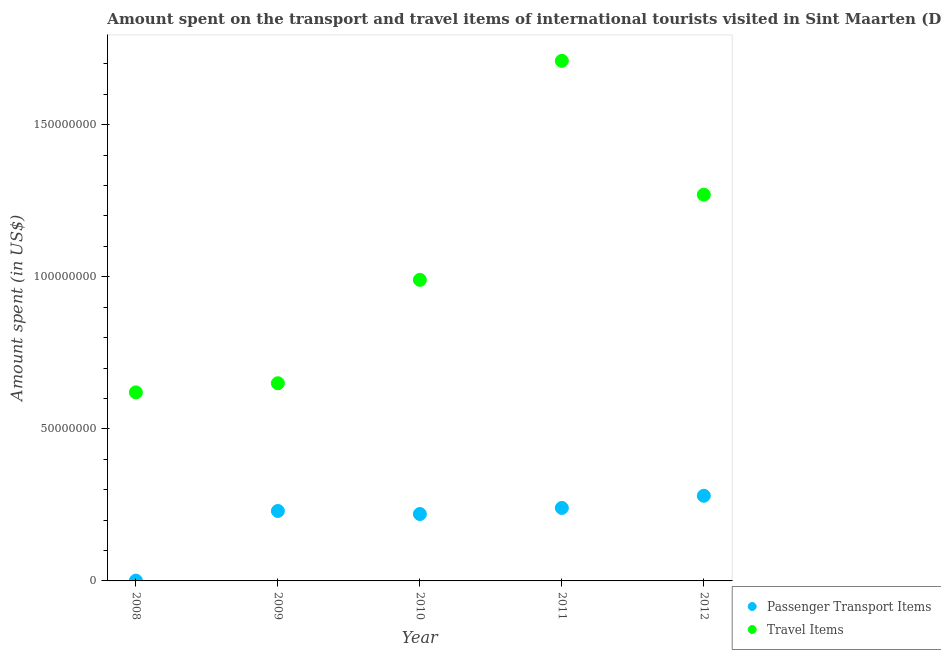Is the number of dotlines equal to the number of legend labels?
Provide a short and direct response. Yes. What is the amount spent on passenger transport items in 2009?
Give a very brief answer. 2.30e+07. Across all years, what is the maximum amount spent on passenger transport items?
Your response must be concise. 2.80e+07. Across all years, what is the minimum amount spent on passenger transport items?
Your answer should be very brief. 1.00e+05. In which year was the amount spent in travel items maximum?
Provide a succinct answer. 2011. What is the total amount spent in travel items in the graph?
Provide a short and direct response. 5.24e+08. What is the difference between the amount spent in travel items in 2008 and that in 2011?
Offer a very short reply. -1.09e+08. What is the difference between the amount spent on passenger transport items in 2010 and the amount spent in travel items in 2012?
Your answer should be very brief. -1.05e+08. What is the average amount spent on passenger transport items per year?
Ensure brevity in your answer.  1.94e+07. In the year 2012, what is the difference between the amount spent in travel items and amount spent on passenger transport items?
Offer a very short reply. 9.90e+07. In how many years, is the amount spent in travel items greater than 30000000 US$?
Give a very brief answer. 5. What is the ratio of the amount spent in travel items in 2009 to that in 2011?
Keep it short and to the point. 0.38. Is the difference between the amount spent on passenger transport items in 2008 and 2009 greater than the difference between the amount spent in travel items in 2008 and 2009?
Give a very brief answer. No. What is the difference between the highest and the second highest amount spent in travel items?
Your answer should be very brief. 4.40e+07. What is the difference between the highest and the lowest amount spent in travel items?
Your response must be concise. 1.09e+08. In how many years, is the amount spent on passenger transport items greater than the average amount spent on passenger transport items taken over all years?
Your answer should be very brief. 4. Is the sum of the amount spent on passenger transport items in 2009 and 2011 greater than the maximum amount spent in travel items across all years?
Offer a very short reply. No. Is the amount spent on passenger transport items strictly less than the amount spent in travel items over the years?
Provide a succinct answer. Yes. How many dotlines are there?
Keep it short and to the point. 2. What is the difference between two consecutive major ticks on the Y-axis?
Your answer should be very brief. 5.00e+07. Does the graph contain any zero values?
Give a very brief answer. No. How are the legend labels stacked?
Keep it short and to the point. Vertical. What is the title of the graph?
Make the answer very short. Amount spent on the transport and travel items of international tourists visited in Sint Maarten (Dutch part). What is the label or title of the Y-axis?
Give a very brief answer. Amount spent (in US$). What is the Amount spent (in US$) in Travel Items in 2008?
Give a very brief answer. 6.20e+07. What is the Amount spent (in US$) of Passenger Transport Items in 2009?
Give a very brief answer. 2.30e+07. What is the Amount spent (in US$) of Travel Items in 2009?
Your answer should be very brief. 6.50e+07. What is the Amount spent (in US$) in Passenger Transport Items in 2010?
Provide a short and direct response. 2.20e+07. What is the Amount spent (in US$) in Travel Items in 2010?
Make the answer very short. 9.90e+07. What is the Amount spent (in US$) of Passenger Transport Items in 2011?
Ensure brevity in your answer.  2.40e+07. What is the Amount spent (in US$) of Travel Items in 2011?
Your answer should be compact. 1.71e+08. What is the Amount spent (in US$) of Passenger Transport Items in 2012?
Ensure brevity in your answer.  2.80e+07. What is the Amount spent (in US$) in Travel Items in 2012?
Your answer should be very brief. 1.27e+08. Across all years, what is the maximum Amount spent (in US$) in Passenger Transport Items?
Offer a terse response. 2.80e+07. Across all years, what is the maximum Amount spent (in US$) of Travel Items?
Your response must be concise. 1.71e+08. Across all years, what is the minimum Amount spent (in US$) of Travel Items?
Your response must be concise. 6.20e+07. What is the total Amount spent (in US$) in Passenger Transport Items in the graph?
Provide a succinct answer. 9.71e+07. What is the total Amount spent (in US$) in Travel Items in the graph?
Provide a succinct answer. 5.24e+08. What is the difference between the Amount spent (in US$) in Passenger Transport Items in 2008 and that in 2009?
Your response must be concise. -2.29e+07. What is the difference between the Amount spent (in US$) of Travel Items in 2008 and that in 2009?
Make the answer very short. -3.00e+06. What is the difference between the Amount spent (in US$) in Passenger Transport Items in 2008 and that in 2010?
Offer a terse response. -2.19e+07. What is the difference between the Amount spent (in US$) in Travel Items in 2008 and that in 2010?
Your answer should be very brief. -3.70e+07. What is the difference between the Amount spent (in US$) of Passenger Transport Items in 2008 and that in 2011?
Offer a very short reply. -2.39e+07. What is the difference between the Amount spent (in US$) of Travel Items in 2008 and that in 2011?
Offer a terse response. -1.09e+08. What is the difference between the Amount spent (in US$) in Passenger Transport Items in 2008 and that in 2012?
Your answer should be very brief. -2.79e+07. What is the difference between the Amount spent (in US$) of Travel Items in 2008 and that in 2012?
Offer a terse response. -6.50e+07. What is the difference between the Amount spent (in US$) in Travel Items in 2009 and that in 2010?
Keep it short and to the point. -3.40e+07. What is the difference between the Amount spent (in US$) in Travel Items in 2009 and that in 2011?
Provide a short and direct response. -1.06e+08. What is the difference between the Amount spent (in US$) in Passenger Transport Items in 2009 and that in 2012?
Provide a succinct answer. -5.00e+06. What is the difference between the Amount spent (in US$) of Travel Items in 2009 and that in 2012?
Provide a succinct answer. -6.20e+07. What is the difference between the Amount spent (in US$) of Travel Items in 2010 and that in 2011?
Offer a very short reply. -7.20e+07. What is the difference between the Amount spent (in US$) of Passenger Transport Items in 2010 and that in 2012?
Offer a terse response. -6.00e+06. What is the difference between the Amount spent (in US$) of Travel Items in 2010 and that in 2012?
Make the answer very short. -2.80e+07. What is the difference between the Amount spent (in US$) in Travel Items in 2011 and that in 2012?
Keep it short and to the point. 4.40e+07. What is the difference between the Amount spent (in US$) of Passenger Transport Items in 2008 and the Amount spent (in US$) of Travel Items in 2009?
Your answer should be very brief. -6.49e+07. What is the difference between the Amount spent (in US$) in Passenger Transport Items in 2008 and the Amount spent (in US$) in Travel Items in 2010?
Your response must be concise. -9.89e+07. What is the difference between the Amount spent (in US$) in Passenger Transport Items in 2008 and the Amount spent (in US$) in Travel Items in 2011?
Keep it short and to the point. -1.71e+08. What is the difference between the Amount spent (in US$) in Passenger Transport Items in 2008 and the Amount spent (in US$) in Travel Items in 2012?
Offer a very short reply. -1.27e+08. What is the difference between the Amount spent (in US$) of Passenger Transport Items in 2009 and the Amount spent (in US$) of Travel Items in 2010?
Offer a very short reply. -7.60e+07. What is the difference between the Amount spent (in US$) in Passenger Transport Items in 2009 and the Amount spent (in US$) in Travel Items in 2011?
Offer a terse response. -1.48e+08. What is the difference between the Amount spent (in US$) in Passenger Transport Items in 2009 and the Amount spent (in US$) in Travel Items in 2012?
Make the answer very short. -1.04e+08. What is the difference between the Amount spent (in US$) in Passenger Transport Items in 2010 and the Amount spent (in US$) in Travel Items in 2011?
Provide a succinct answer. -1.49e+08. What is the difference between the Amount spent (in US$) of Passenger Transport Items in 2010 and the Amount spent (in US$) of Travel Items in 2012?
Your answer should be very brief. -1.05e+08. What is the difference between the Amount spent (in US$) of Passenger Transport Items in 2011 and the Amount spent (in US$) of Travel Items in 2012?
Offer a terse response. -1.03e+08. What is the average Amount spent (in US$) of Passenger Transport Items per year?
Keep it short and to the point. 1.94e+07. What is the average Amount spent (in US$) of Travel Items per year?
Provide a succinct answer. 1.05e+08. In the year 2008, what is the difference between the Amount spent (in US$) in Passenger Transport Items and Amount spent (in US$) in Travel Items?
Your answer should be very brief. -6.19e+07. In the year 2009, what is the difference between the Amount spent (in US$) in Passenger Transport Items and Amount spent (in US$) in Travel Items?
Ensure brevity in your answer.  -4.20e+07. In the year 2010, what is the difference between the Amount spent (in US$) of Passenger Transport Items and Amount spent (in US$) of Travel Items?
Keep it short and to the point. -7.70e+07. In the year 2011, what is the difference between the Amount spent (in US$) of Passenger Transport Items and Amount spent (in US$) of Travel Items?
Make the answer very short. -1.47e+08. In the year 2012, what is the difference between the Amount spent (in US$) of Passenger Transport Items and Amount spent (in US$) of Travel Items?
Provide a succinct answer. -9.90e+07. What is the ratio of the Amount spent (in US$) of Passenger Transport Items in 2008 to that in 2009?
Provide a succinct answer. 0. What is the ratio of the Amount spent (in US$) in Travel Items in 2008 to that in 2009?
Keep it short and to the point. 0.95. What is the ratio of the Amount spent (in US$) of Passenger Transport Items in 2008 to that in 2010?
Provide a short and direct response. 0. What is the ratio of the Amount spent (in US$) of Travel Items in 2008 to that in 2010?
Provide a short and direct response. 0.63. What is the ratio of the Amount spent (in US$) of Passenger Transport Items in 2008 to that in 2011?
Provide a short and direct response. 0. What is the ratio of the Amount spent (in US$) of Travel Items in 2008 to that in 2011?
Ensure brevity in your answer.  0.36. What is the ratio of the Amount spent (in US$) of Passenger Transport Items in 2008 to that in 2012?
Your answer should be compact. 0. What is the ratio of the Amount spent (in US$) in Travel Items in 2008 to that in 2012?
Ensure brevity in your answer.  0.49. What is the ratio of the Amount spent (in US$) in Passenger Transport Items in 2009 to that in 2010?
Provide a short and direct response. 1.05. What is the ratio of the Amount spent (in US$) in Travel Items in 2009 to that in 2010?
Keep it short and to the point. 0.66. What is the ratio of the Amount spent (in US$) in Travel Items in 2009 to that in 2011?
Offer a terse response. 0.38. What is the ratio of the Amount spent (in US$) in Passenger Transport Items in 2009 to that in 2012?
Ensure brevity in your answer.  0.82. What is the ratio of the Amount spent (in US$) of Travel Items in 2009 to that in 2012?
Your response must be concise. 0.51. What is the ratio of the Amount spent (in US$) in Passenger Transport Items in 2010 to that in 2011?
Provide a succinct answer. 0.92. What is the ratio of the Amount spent (in US$) in Travel Items in 2010 to that in 2011?
Provide a succinct answer. 0.58. What is the ratio of the Amount spent (in US$) of Passenger Transport Items in 2010 to that in 2012?
Your response must be concise. 0.79. What is the ratio of the Amount spent (in US$) of Travel Items in 2010 to that in 2012?
Your answer should be very brief. 0.78. What is the ratio of the Amount spent (in US$) of Passenger Transport Items in 2011 to that in 2012?
Ensure brevity in your answer.  0.86. What is the ratio of the Amount spent (in US$) of Travel Items in 2011 to that in 2012?
Offer a terse response. 1.35. What is the difference between the highest and the second highest Amount spent (in US$) of Passenger Transport Items?
Provide a short and direct response. 4.00e+06. What is the difference between the highest and the second highest Amount spent (in US$) in Travel Items?
Ensure brevity in your answer.  4.40e+07. What is the difference between the highest and the lowest Amount spent (in US$) of Passenger Transport Items?
Provide a short and direct response. 2.79e+07. What is the difference between the highest and the lowest Amount spent (in US$) in Travel Items?
Offer a very short reply. 1.09e+08. 